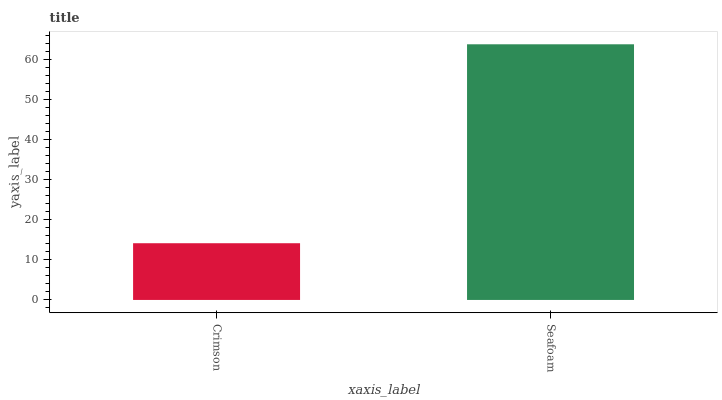Is Crimson the minimum?
Answer yes or no. Yes. Is Seafoam the maximum?
Answer yes or no. Yes. Is Seafoam the minimum?
Answer yes or no. No. Is Seafoam greater than Crimson?
Answer yes or no. Yes. Is Crimson less than Seafoam?
Answer yes or no. Yes. Is Crimson greater than Seafoam?
Answer yes or no. No. Is Seafoam less than Crimson?
Answer yes or no. No. Is Seafoam the high median?
Answer yes or no. Yes. Is Crimson the low median?
Answer yes or no. Yes. Is Crimson the high median?
Answer yes or no. No. Is Seafoam the low median?
Answer yes or no. No. 